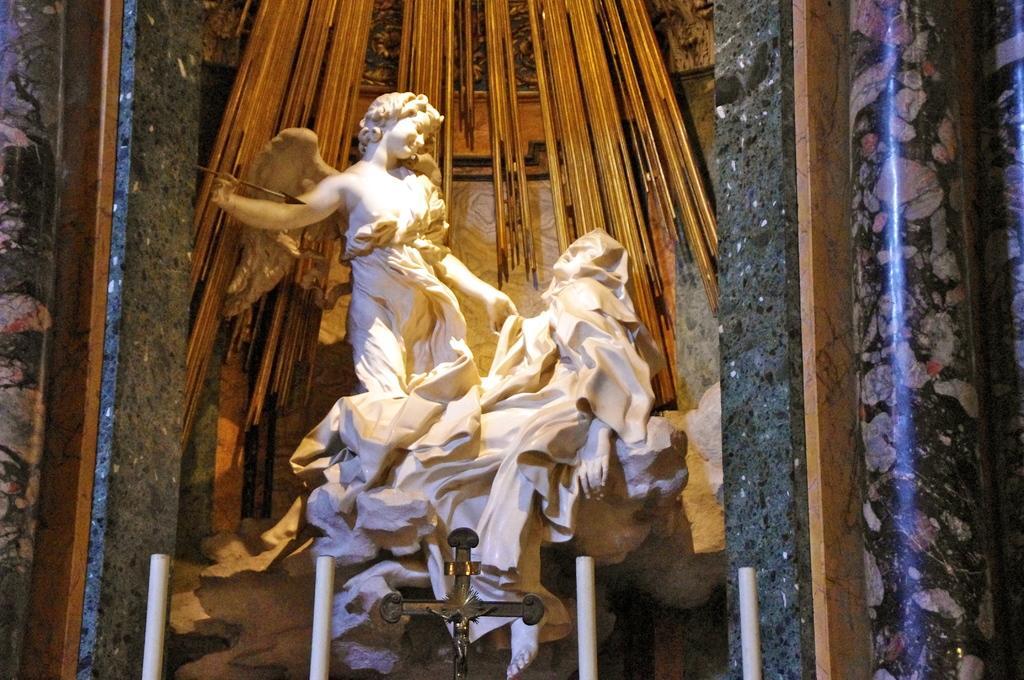How would you summarize this image in a sentence or two? In this image we can see some sculptures. 